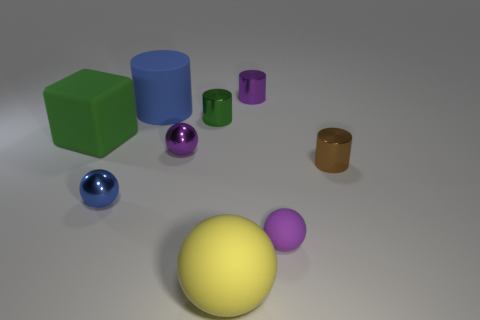Add 1 yellow things. How many objects exist? 10 Subtract all cylinders. How many objects are left? 5 Subtract 0 gray spheres. How many objects are left? 9 Subtract all purple rubber things. Subtract all large rubber blocks. How many objects are left? 7 Add 1 large rubber cylinders. How many large rubber cylinders are left? 2 Add 6 large blue matte cylinders. How many large blue matte cylinders exist? 7 